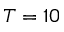<formula> <loc_0><loc_0><loc_500><loc_500>T = 1 0</formula> 